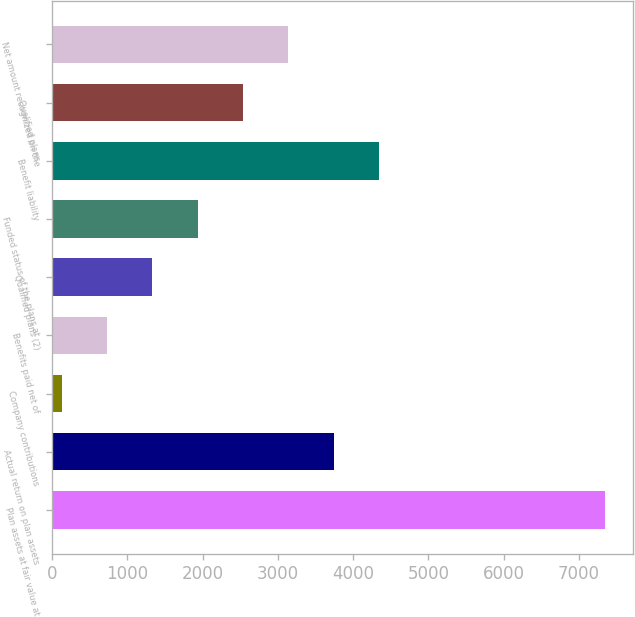<chart> <loc_0><loc_0><loc_500><loc_500><bar_chart><fcel>Plan assets at fair value at<fcel>Actual return on plan assets<fcel>Company contributions<fcel>Benefits paid net of<fcel>Qualified plans (2)<fcel>Funded status of the plans at<fcel>Benefit liability<fcel>Qualified plans<fcel>Net amount recognized on the<nl><fcel>7353.6<fcel>3739.8<fcel>126<fcel>728.3<fcel>1330.6<fcel>1932.9<fcel>4342.1<fcel>2535.2<fcel>3137.5<nl></chart> 